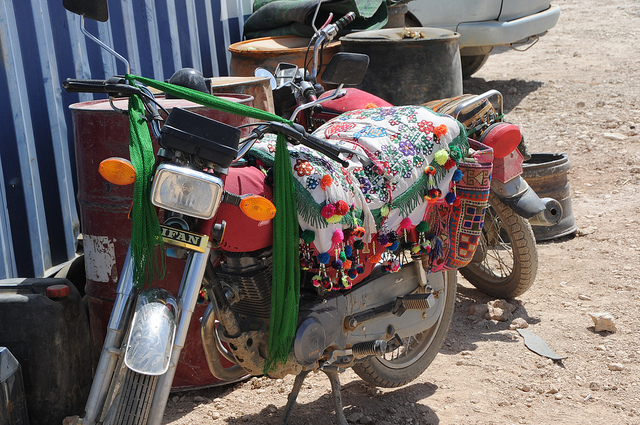Please identify all text content in this image. IFAN 